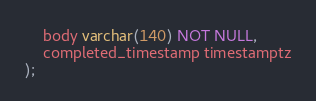Convert code to text. <code><loc_0><loc_0><loc_500><loc_500><_SQL_>    body varchar(140) NOT NULL,
    completed_timestamp timestamptz
);
</code> 